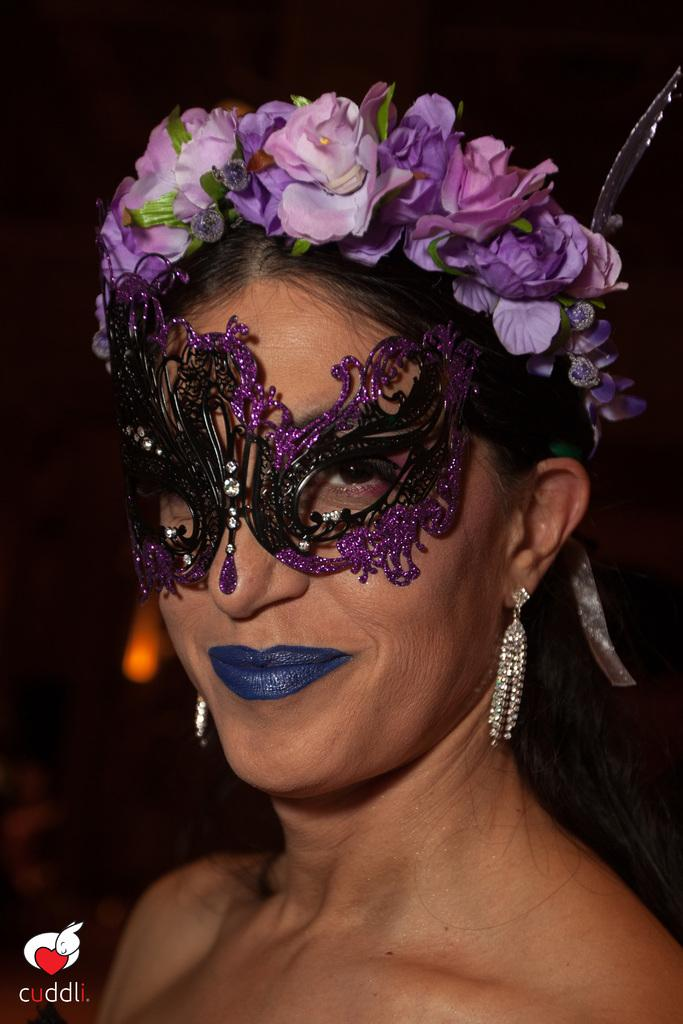Who is present in the image? There is a woman in the image. What is the woman doing in the image? The woman is smiling in the image. What is the woman wearing on her face? The woman is wearing a mask in the image. What is the woman wearing on her head? The woman is wearing a crown in the image. What can be seen at the bottom left corner of the image? There are icons and text on the left side bottom of the image. What type of office equipment can be seen in the image? There is no office equipment present in the image. How does the woman measure the distance between the two rocks in the image? There are no rocks present in the image, and the woman is not measuring any distances. 